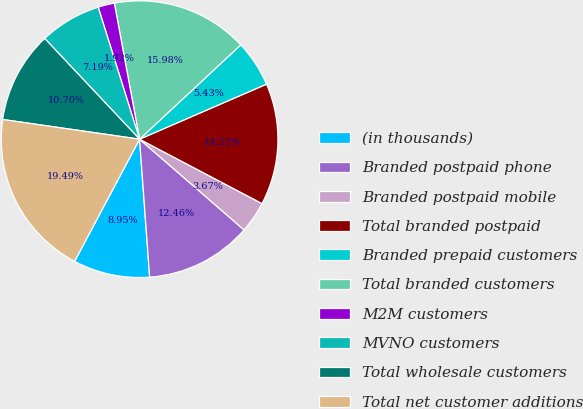Convert chart. <chart><loc_0><loc_0><loc_500><loc_500><pie_chart><fcel>(in thousands)<fcel>Branded postpaid phone<fcel>Branded postpaid mobile<fcel>Total branded postpaid<fcel>Branded prepaid customers<fcel>Total branded customers<fcel>M2M customers<fcel>MVNO customers<fcel>Total wholesale customers<fcel>Total net customer additions<nl><fcel>8.95%<fcel>12.46%<fcel>3.67%<fcel>14.22%<fcel>5.43%<fcel>15.98%<fcel>1.92%<fcel>7.19%<fcel>10.7%<fcel>19.49%<nl></chart> 